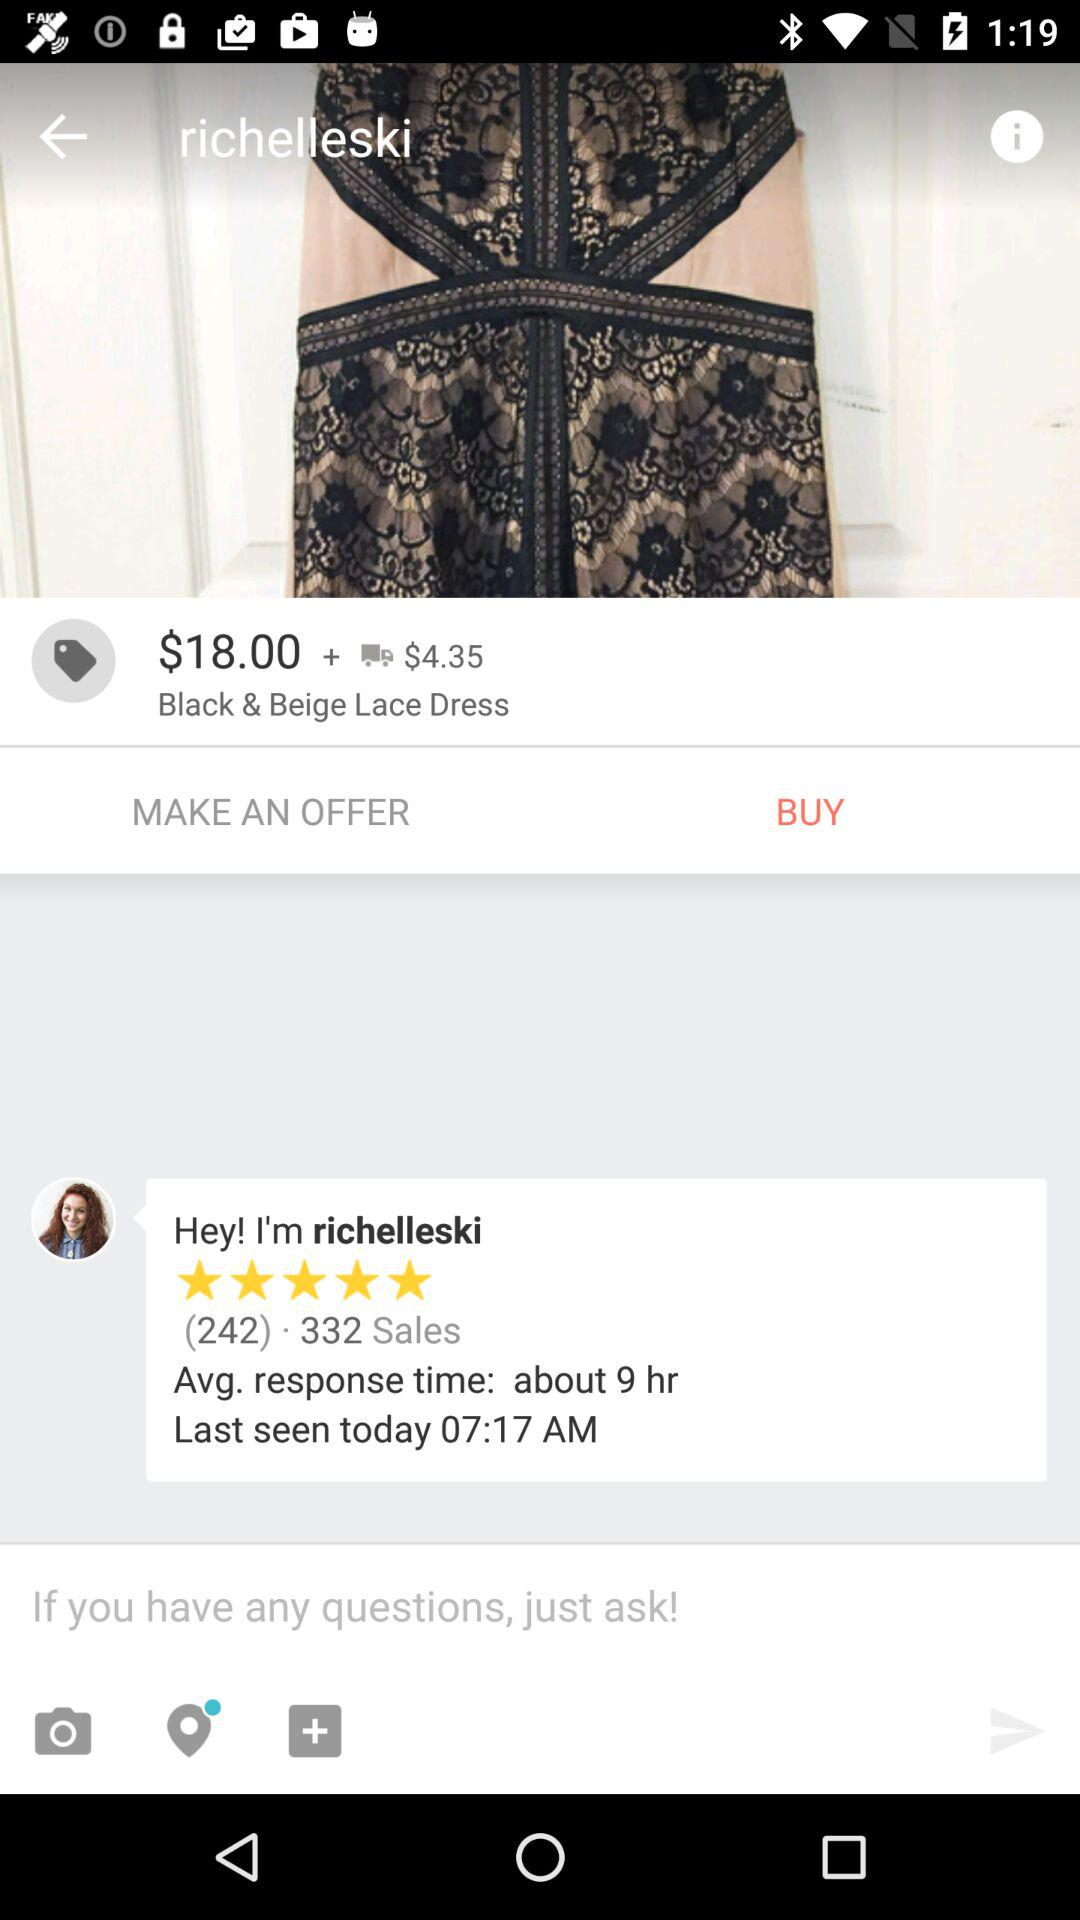At what time was Richelleski last online? Richelleski was last online at 7:17 a.m. today. 